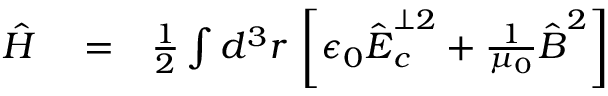<formula> <loc_0><loc_0><loc_500><loc_500>\begin{array} { r l r } { \hat { H } } & = } & { \frac { 1 } { 2 } \int d ^ { 3 } \boldsymbol r \, \left [ \epsilon _ { 0 } \hat { \boldsymbol E } _ { c } ^ { \perp 2 } + \frac { 1 } { \mu _ { 0 } } \hat { \boldsymbol B } ^ { 2 } \right ] } \end{array}</formula> 